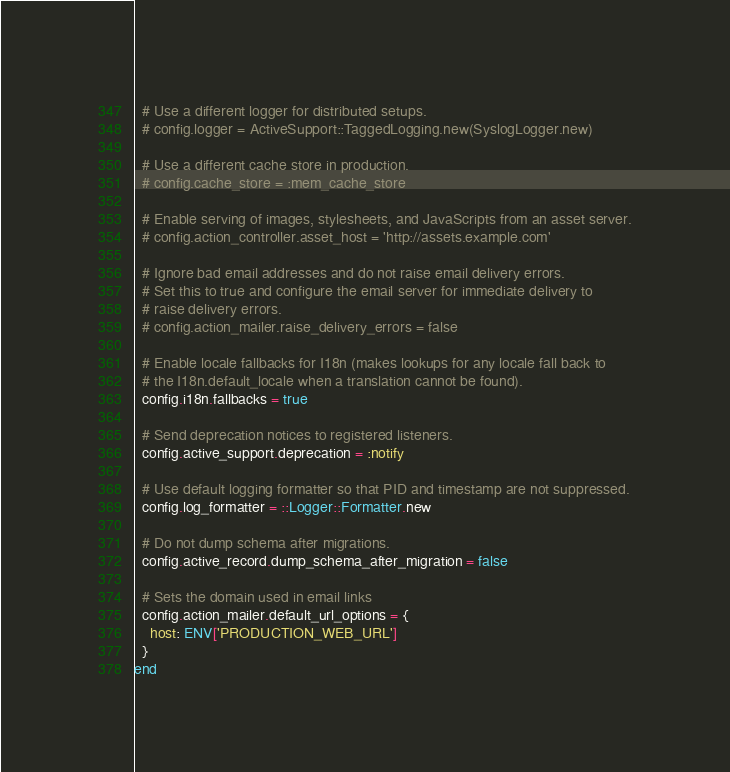Convert code to text. <code><loc_0><loc_0><loc_500><loc_500><_Ruby_>
  # Use a different logger for distributed setups.
  # config.logger = ActiveSupport::TaggedLogging.new(SyslogLogger.new)

  # Use a different cache store in production.
  # config.cache_store = :mem_cache_store

  # Enable serving of images, stylesheets, and JavaScripts from an asset server.
  # config.action_controller.asset_host = 'http://assets.example.com'

  # Ignore bad email addresses and do not raise email delivery errors.
  # Set this to true and configure the email server for immediate delivery to
  # raise delivery errors.
  # config.action_mailer.raise_delivery_errors = false

  # Enable locale fallbacks for I18n (makes lookups for any locale fall back to
  # the I18n.default_locale when a translation cannot be found).
  config.i18n.fallbacks = true

  # Send deprecation notices to registered listeners.
  config.active_support.deprecation = :notify

  # Use default logging formatter so that PID and timestamp are not suppressed.
  config.log_formatter = ::Logger::Formatter.new

  # Do not dump schema after migrations.
  config.active_record.dump_schema_after_migration = false

  # Sets the domain used in email links
  config.action_mailer.default_url_options = {
    host: ENV['PRODUCTION_WEB_URL']
  }
end
</code> 